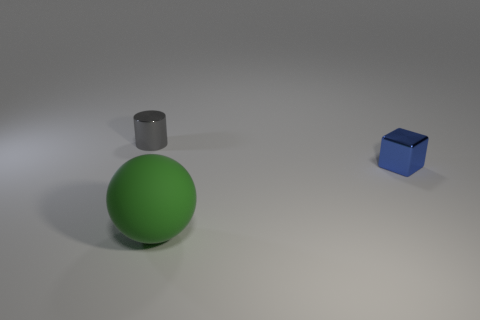What number of objects are either small gray metal objects or things on the left side of the blue block?
Keep it short and to the point. 2. How many other things are the same size as the metal cube?
Ensure brevity in your answer.  1. Are the object right of the big green sphere and the small thing to the left of the large green object made of the same material?
Your answer should be compact. Yes. There is a small blue thing; how many small shiny blocks are behind it?
Make the answer very short. 0. How many gray things are either tiny cylinders or big balls?
Give a very brief answer. 1. There is a gray thing that is the same size as the shiny cube; what is it made of?
Your answer should be very brief. Metal. There is a object that is to the left of the small blue metallic cube and behind the big green rubber sphere; what is its shape?
Keep it short and to the point. Cylinder. The cube that is the same size as the shiny cylinder is what color?
Your answer should be very brief. Blue. There is a metallic thing that is to the left of the big ball; is its size the same as the thing right of the rubber object?
Give a very brief answer. Yes. What size is the metallic object to the right of the shiny thing that is to the left of the metal object in front of the gray cylinder?
Ensure brevity in your answer.  Small. 